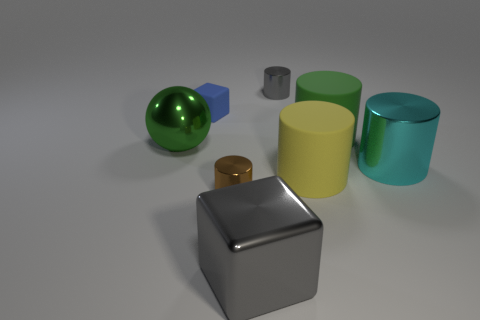Is there a metallic cube of the same size as the gray cylinder?
Make the answer very short. No. The ball that is made of the same material as the gray cylinder is what size?
Your answer should be very brief. Large. There is a blue rubber object; what shape is it?
Provide a short and direct response. Cube. Are the tiny blue thing and the tiny thing that is to the right of the brown cylinder made of the same material?
Offer a very short reply. No. What number of things are big gray things or small red matte spheres?
Your response must be concise. 1. Are there any shiny cylinders?
Offer a terse response. Yes. There is a gray object in front of the block that is left of the large gray metal cube; what shape is it?
Your response must be concise. Cube. How many objects are either cubes that are in front of the green rubber thing or large spheres that are in front of the green cylinder?
Keep it short and to the point. 2. There is a green cylinder that is the same size as the gray block; what is it made of?
Your answer should be very brief. Rubber. The rubber cube has what color?
Offer a very short reply. Blue. 